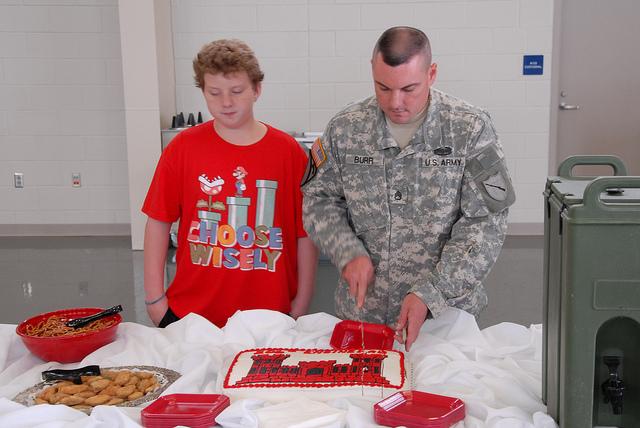What kind of suit are the men wearing?
Short answer required. Army. Has anyone eaten any of the cake yet?
Write a very short answer. No. What country is the army man from?
Be succinct. Usa. What is the man doing?
Be succinct. Cutting cake. 